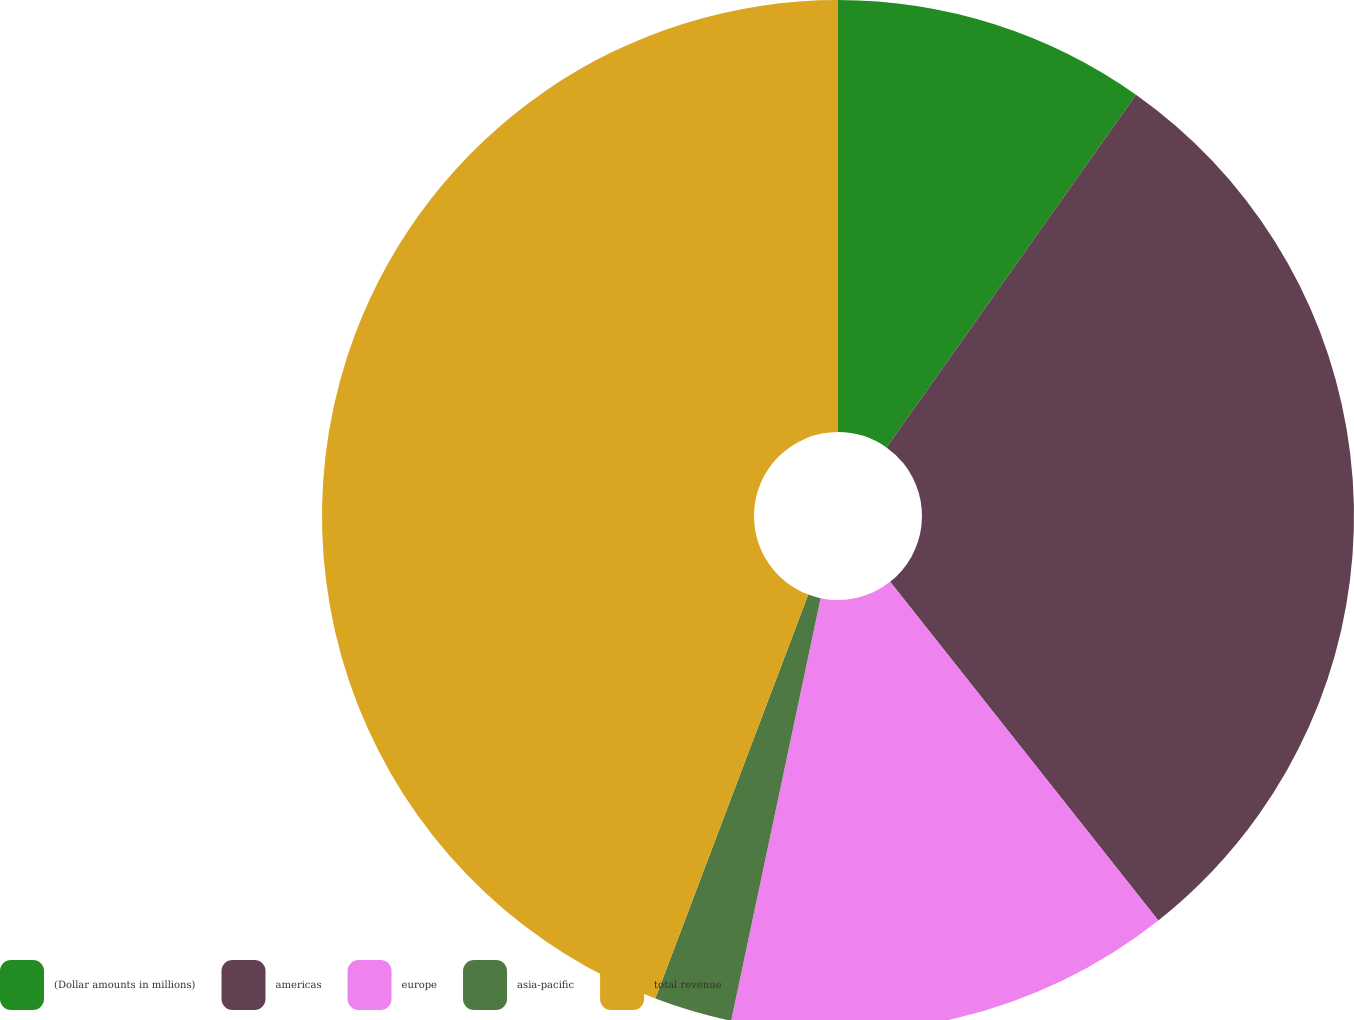Convert chart to OTSL. <chart><loc_0><loc_0><loc_500><loc_500><pie_chart><fcel>(Dollar amounts in millions)<fcel>americas<fcel>europe<fcel>asia-pacific<fcel>total revenue<nl><fcel>9.8%<fcel>29.54%<fcel>13.98%<fcel>2.44%<fcel>44.24%<nl></chart> 